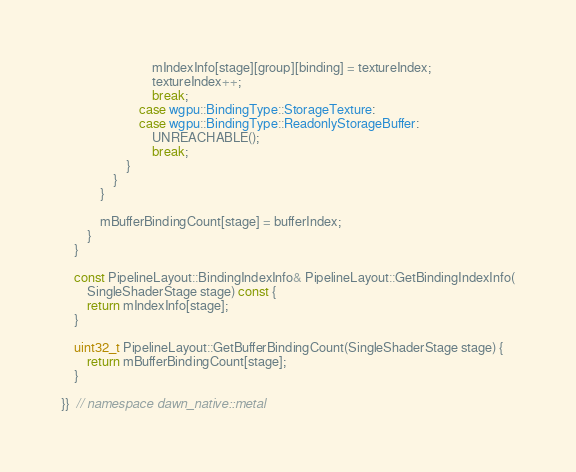<code> <loc_0><loc_0><loc_500><loc_500><_ObjectiveC_>                            mIndexInfo[stage][group][binding] = textureIndex;
                            textureIndex++;
                            break;
                        case wgpu::BindingType::StorageTexture:
                        case wgpu::BindingType::ReadonlyStorageBuffer:
                            UNREACHABLE();
                            break;
                    }
                }
            }

            mBufferBindingCount[stage] = bufferIndex;
        }
    }

    const PipelineLayout::BindingIndexInfo& PipelineLayout::GetBindingIndexInfo(
        SingleShaderStage stage) const {
        return mIndexInfo[stage];
    }

    uint32_t PipelineLayout::GetBufferBindingCount(SingleShaderStage stage) {
        return mBufferBindingCount[stage];
    }

}}  // namespace dawn_native::metal
</code> 